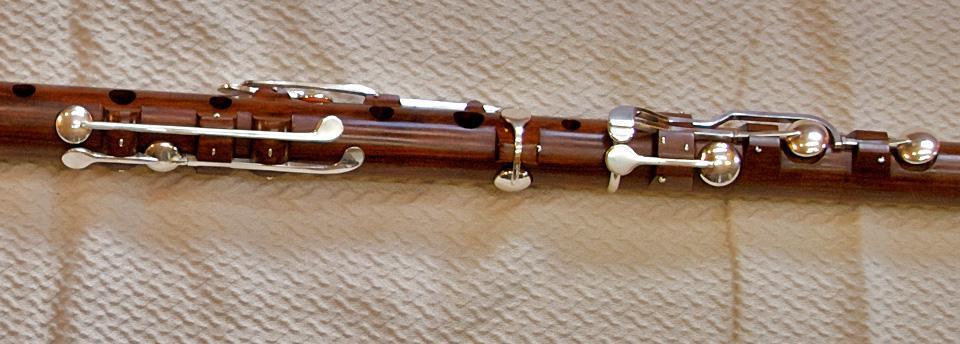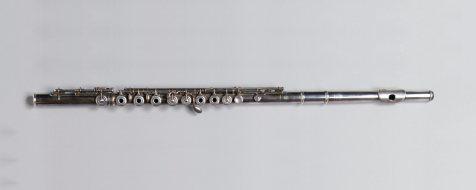The first image is the image on the left, the second image is the image on the right. For the images shown, is this caption "Exactly two mouthpieces are visible." true? Answer yes or no. No. 